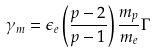<formula> <loc_0><loc_0><loc_500><loc_500>\gamma _ { m } = \epsilon _ { e } \left ( \frac { p - 2 } { p - 1 } \right ) \frac { m _ { p } } { m _ { e } } \Gamma</formula> 